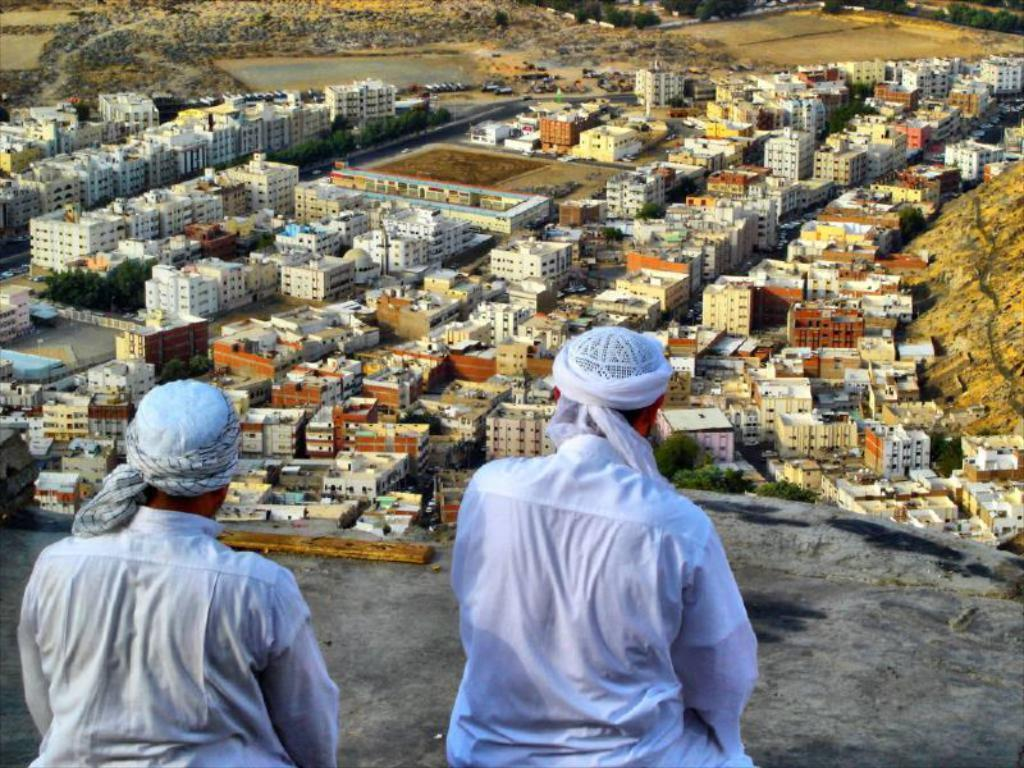How many people are in the image? There are two men in the image. What are the men doing in the image? The men are on a surface, but their specific activity is not clear from the provided facts. What can be seen in the background of the image? There is a group of buildings, trees, and a water body in the background of the image. What type of toy can be seen in the hands of one of the men in the image? There is no toy present in the image; it only features two men and the background elements. 